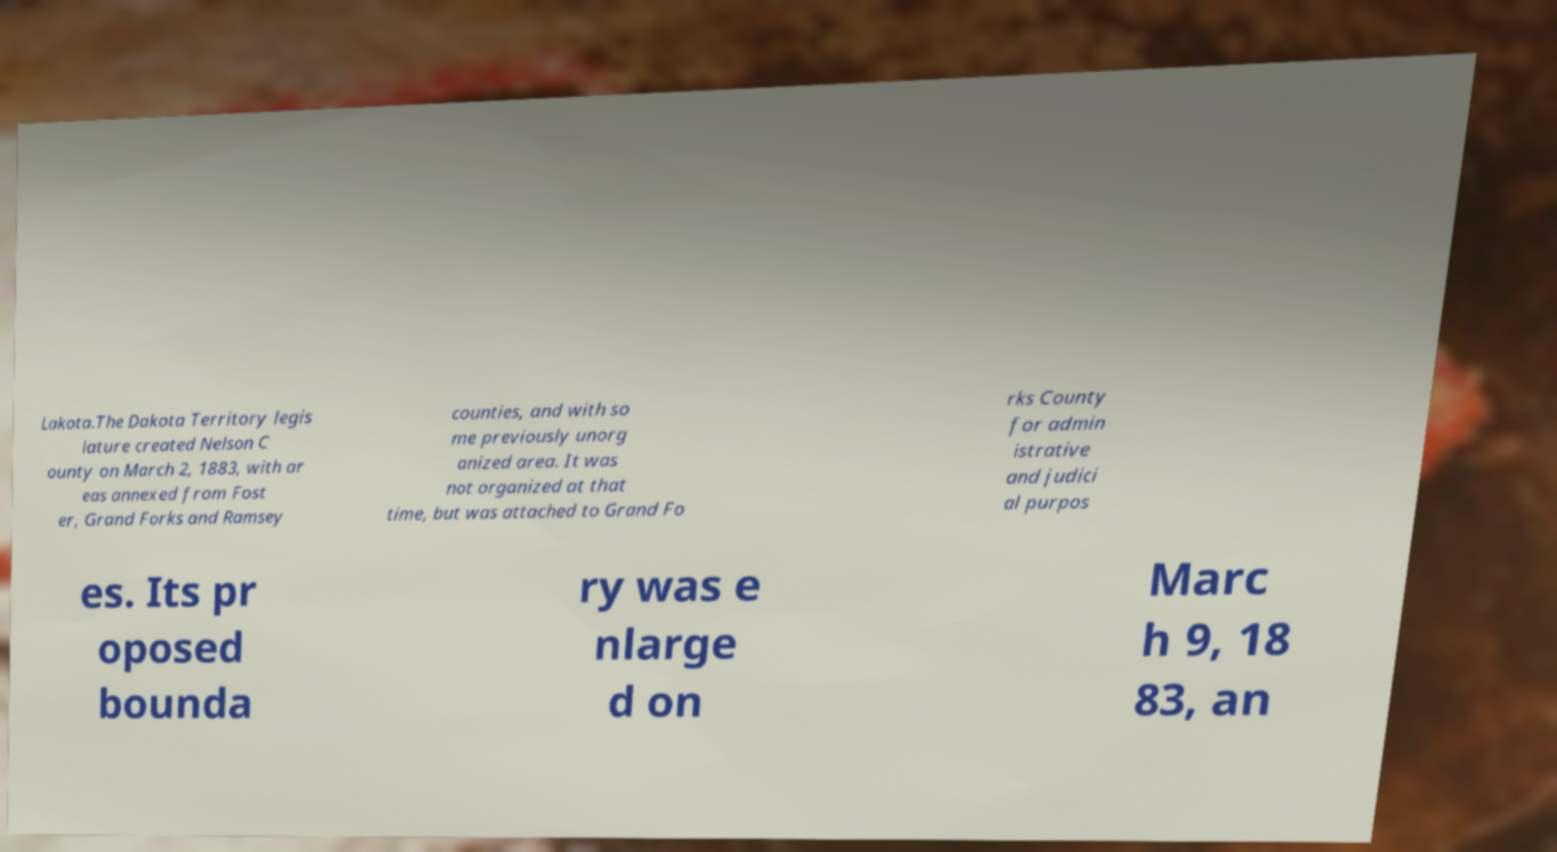Please read and relay the text visible in this image. What does it say? Lakota.The Dakota Territory legis lature created Nelson C ounty on March 2, 1883, with ar eas annexed from Fost er, Grand Forks and Ramsey counties, and with so me previously unorg anized area. It was not organized at that time, but was attached to Grand Fo rks County for admin istrative and judici al purpos es. Its pr oposed bounda ry was e nlarge d on Marc h 9, 18 83, an 